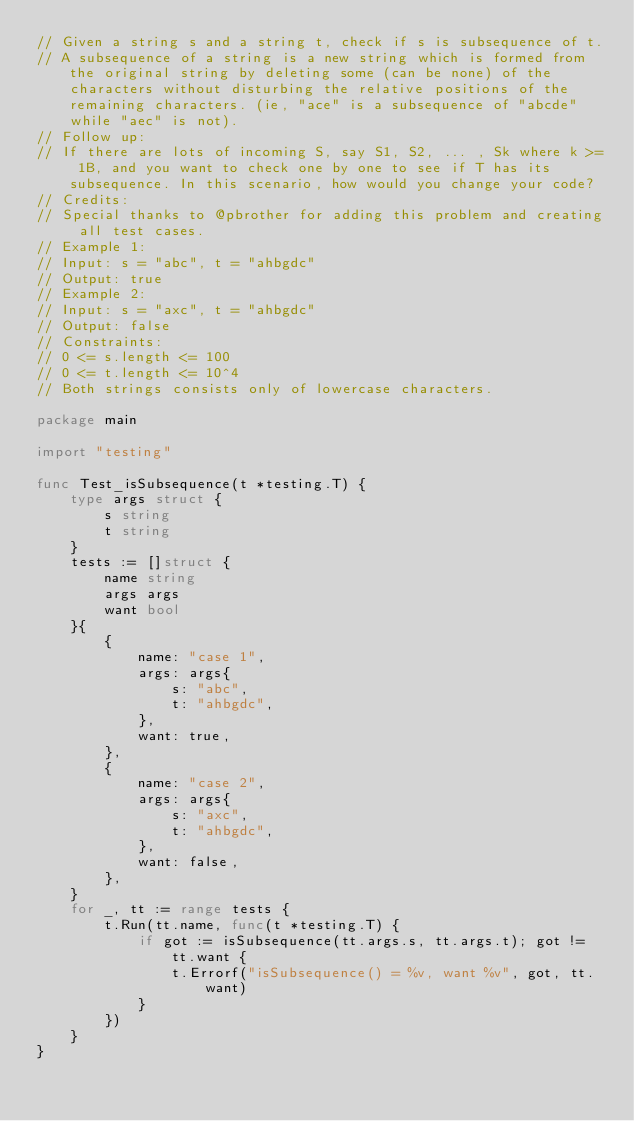<code> <loc_0><loc_0><loc_500><loc_500><_Go_>// Given a string s and a string t, check if s is subsequence of t.
// A subsequence of a string is a new string which is formed from the original string by deleting some (can be none) of the characters without disturbing the relative positions of the remaining characters. (ie, "ace" is a subsequence of "abcde" while "aec" is not).
// Follow up:
// If there are lots of incoming S, say S1, S2, ... , Sk where k >= 1B, and you want to check one by one to see if T has its subsequence. In this scenario, how would you change your code?
// Credits:
// Special thanks to @pbrother for adding this problem and creating all test cases.
// Example 1:
// Input: s = "abc", t = "ahbgdc"
// Output: true
// Example 2:
// Input: s = "axc", t = "ahbgdc"
// Output: false
// Constraints:
// 0 <= s.length <= 100
// 0 <= t.length <= 10^4
// Both strings consists only of lowercase characters.

package main

import "testing"

func Test_isSubsequence(t *testing.T) {
	type args struct {
		s string
		t string
	}
	tests := []struct {
		name string
		args args
		want bool
	}{
		{
			name: "case 1",
			args: args{
				s: "abc",
				t: "ahbgdc",
			},
			want: true,
		},
		{
			name: "case 2",
			args: args{
				s: "axc",
				t: "ahbgdc",
			},
			want: false,
		},
	}
	for _, tt := range tests {
		t.Run(tt.name, func(t *testing.T) {
			if got := isSubsequence(tt.args.s, tt.args.t); got != tt.want {
				t.Errorf("isSubsequence() = %v, want %v", got, tt.want)
			}
		})
	}
}
</code> 